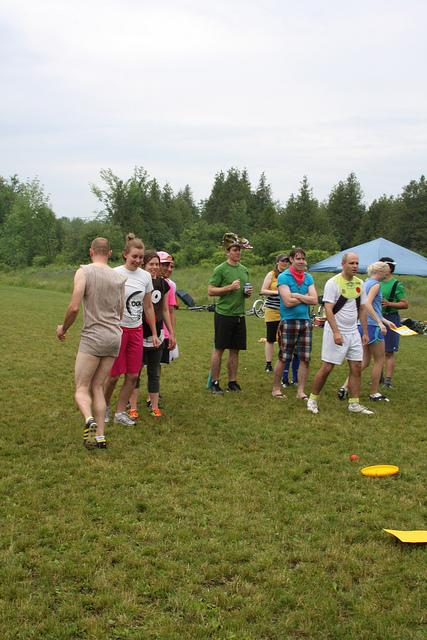Where are they playing a game? field 